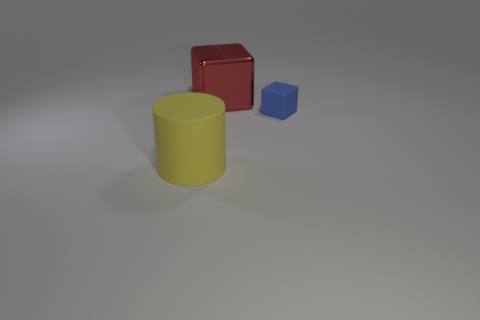The large object that is in front of the blue object has what shape?
Ensure brevity in your answer.  Cylinder. There is a thing that is to the left of the big object behind the rubber thing on the right side of the rubber cylinder; how big is it?
Offer a very short reply. Large. Is the tiny blue object the same shape as the big metallic thing?
Provide a succinct answer. Yes. There is a thing that is both in front of the red shiny block and to the left of the tiny blue matte block; what is its size?
Ensure brevity in your answer.  Large. There is another thing that is the same shape as the large red object; what is it made of?
Provide a short and direct response. Rubber. There is a thing that is in front of the block that is in front of the large shiny thing; what is it made of?
Your answer should be compact. Rubber. There is a big shiny object; does it have the same shape as the rubber thing to the left of the tiny thing?
Offer a terse response. No. What number of matte things are either tiny cyan spheres or tiny blue objects?
Offer a very short reply. 1. What is the color of the matte object that is behind the matte thing that is on the left side of the matte thing that is behind the matte cylinder?
Give a very brief answer. Blue. What number of other objects are the same material as the big red object?
Make the answer very short. 0. 